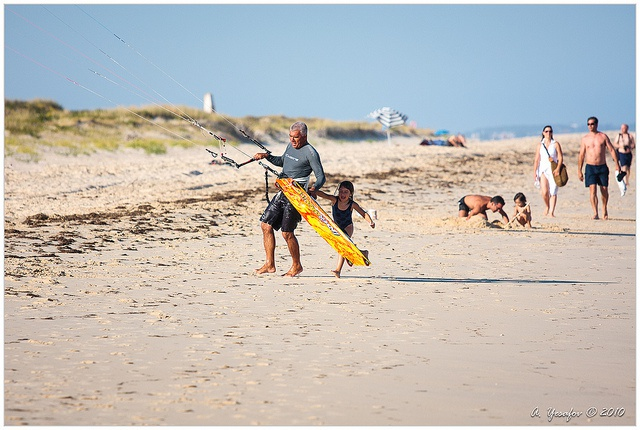Describe the objects in this image and their specific colors. I can see people in white, black, gray, darkgray, and maroon tones, people in white, salmon, black, tan, and brown tones, surfboard in white, gold, orange, red, and khaki tones, people in white, tan, and brown tones, and people in white, black, maroon, and brown tones in this image. 